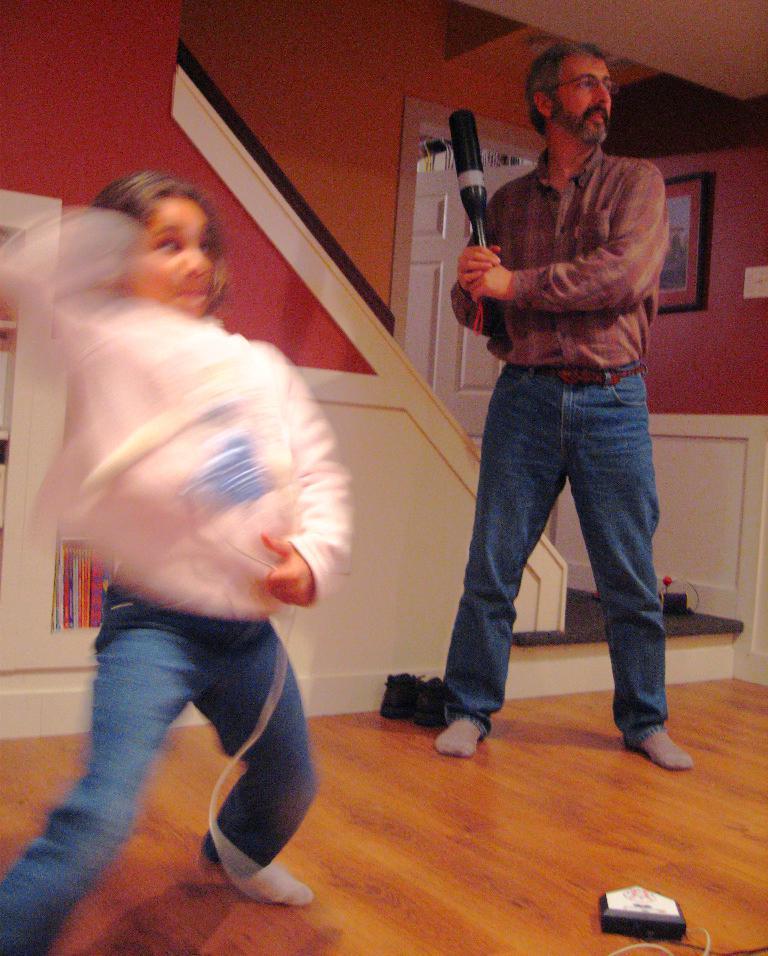Describe this image in one or two sentences. In this image I can see two persons standing. In front the person is wearing brown and blue color dress and holding some object. In the background I can see the frame attached to the wall and the wall is in brown color and I can see the door in white color. 